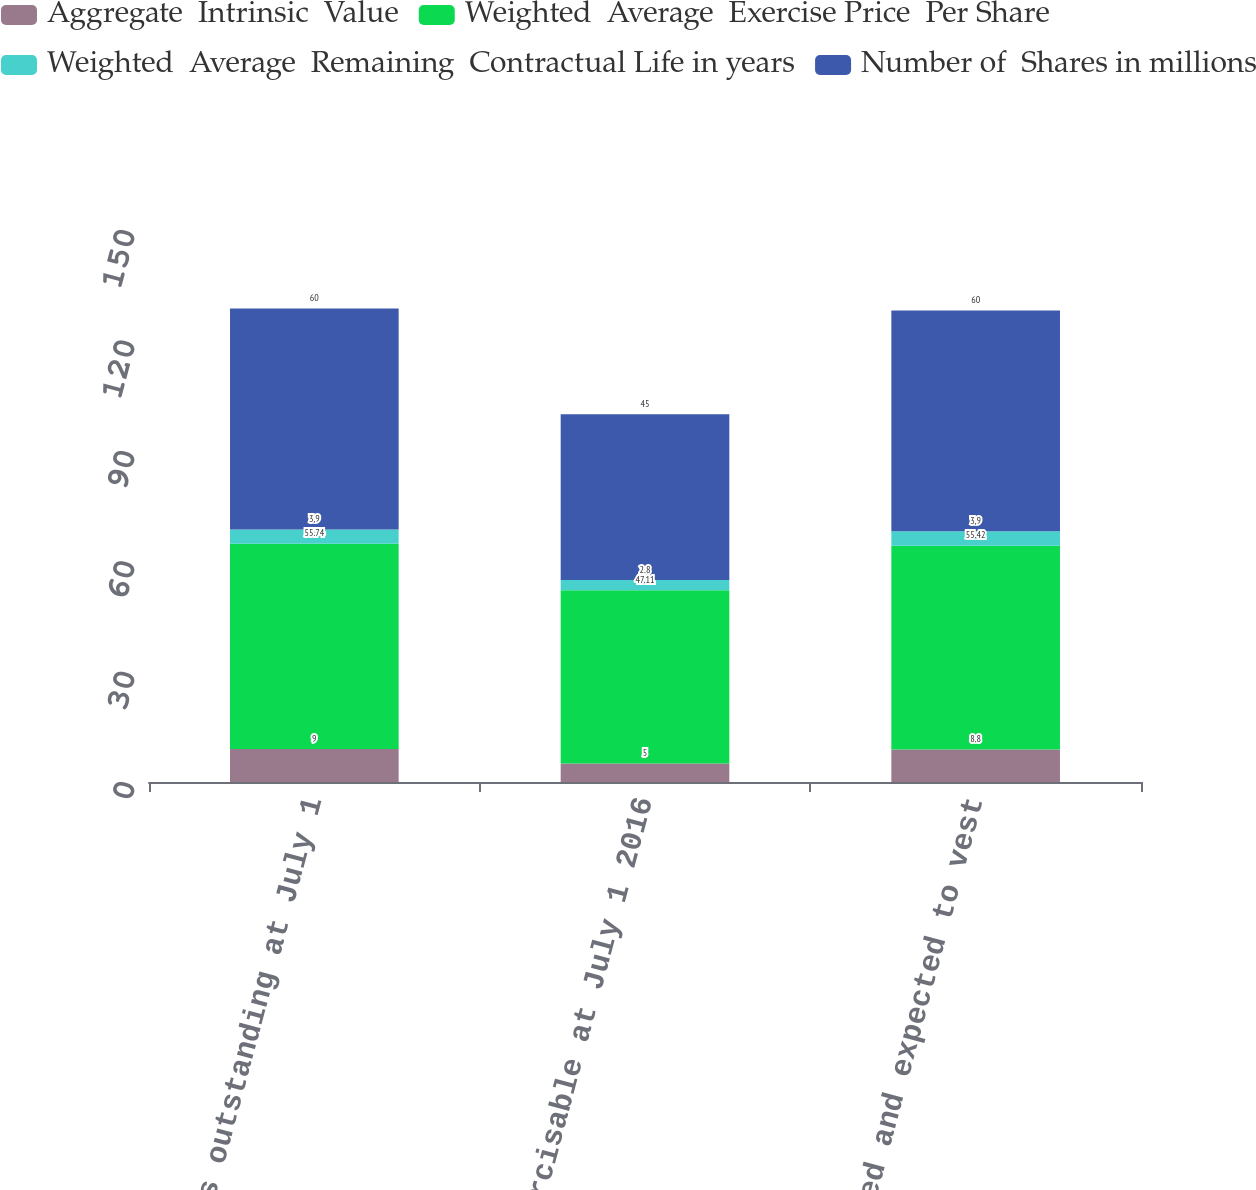Convert chart. <chart><loc_0><loc_0><loc_500><loc_500><stacked_bar_chart><ecel><fcel>Options outstanding at July 1<fcel>Exercisable at July 1 2016<fcel>Vested and expected to vest<nl><fcel>Aggregate  Intrinsic  Value<fcel>9<fcel>5<fcel>8.8<nl><fcel>Weighted  Average  Exercise Price  Per Share<fcel>55.74<fcel>47.11<fcel>55.42<nl><fcel>Weighted  Average  Remaining  Contractual Life in years<fcel>3.9<fcel>2.8<fcel>3.9<nl><fcel>Number of  Shares in millions<fcel>60<fcel>45<fcel>60<nl></chart> 